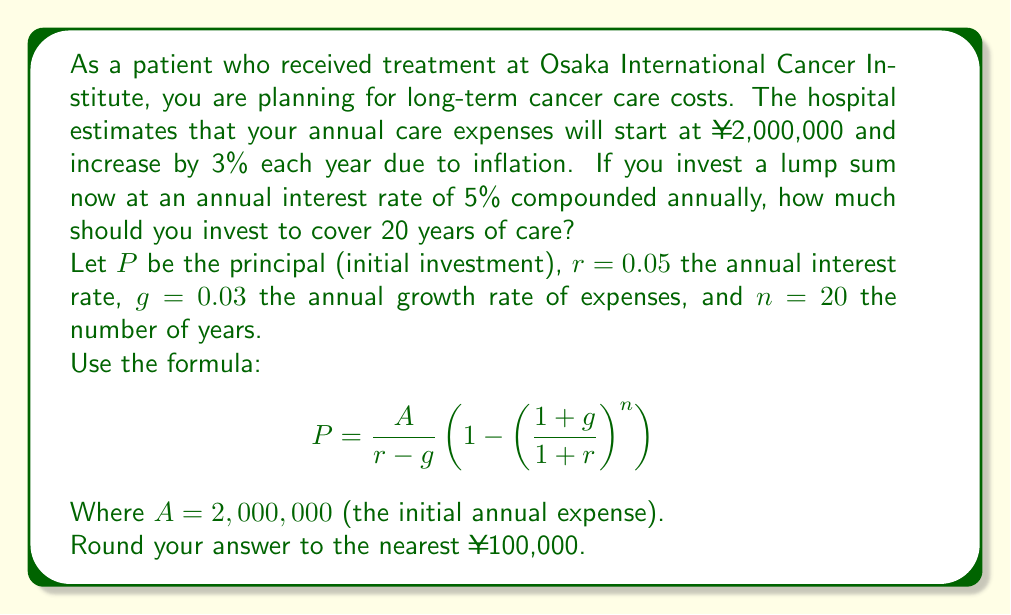Teach me how to tackle this problem. To solve this problem, we'll use the given formula and follow these steps:

1) First, let's identify our variables:
   $A = 2,000,000$ (initial annual expense)
   $r = 0.05$ (annual interest rate)
   $g = 0.03$ (annual growth rate of expenses)
   $n = 20$ (number of years)

2) Now, let's substitute these values into the formula:

   $P = \frac{2,000,000}{0.05-0.03} \left(1 - \left(\frac{1+0.03}{1+0.05}\right)^{20}\right)$

3) Simplify the fraction in the parentheses:
   
   $P = \frac{2,000,000}{0.02} \left(1 - \left(\frac{1.03}{1.05}\right)^{20}\right)$

4) Calculate the power term:
   
   $\left(\frac{1.03}{1.05}\right)^{20} \approx 0.6730$

5) Substitute this value:

   $P = 100,000,000 \times (1 - 0.6730)$

6) Calculate:

   $P = 100,000,000 \times 0.3270 = 32,700,000$

7) Round to the nearest ¥100,000:

   $P \approx 32,700,000$

Therefore, you should invest approximately ¥32,700,000 now to cover 20 years of care.
Answer: ¥32,700,000 